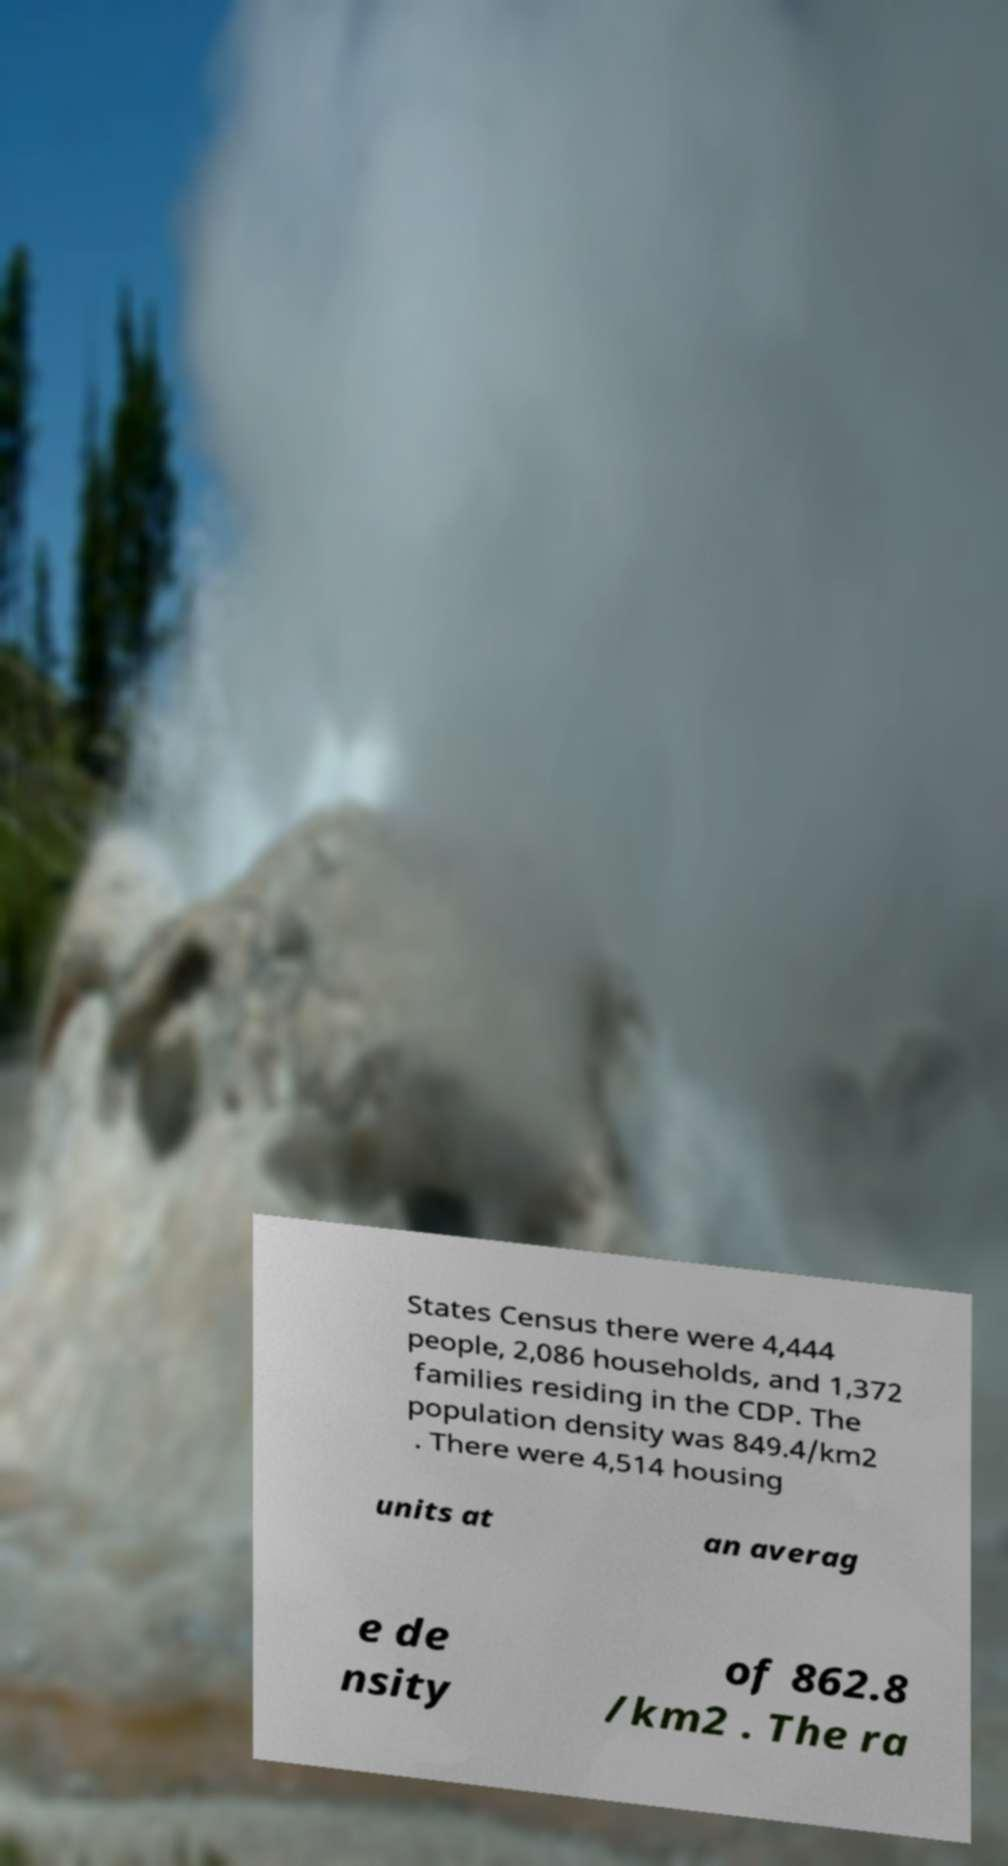What messages or text are displayed in this image? I need them in a readable, typed format. States Census there were 4,444 people, 2,086 households, and 1,372 families residing in the CDP. The population density was 849.4/km2 . There were 4,514 housing units at an averag e de nsity of 862.8 /km2 . The ra 